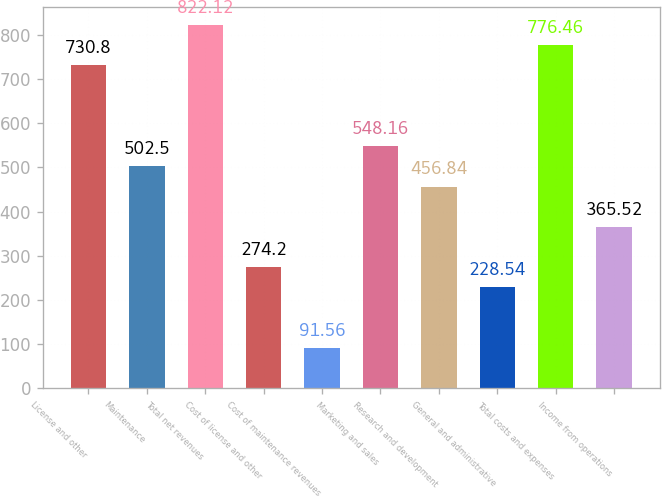Convert chart. <chart><loc_0><loc_0><loc_500><loc_500><bar_chart><fcel>License and other<fcel>Maintenance<fcel>Total net revenues<fcel>Cost of license and other<fcel>Cost of maintenance revenues<fcel>Marketing and sales<fcel>Research and development<fcel>General and administrative<fcel>Total costs and expenses<fcel>Income from operations<nl><fcel>730.8<fcel>502.5<fcel>822.12<fcel>274.2<fcel>91.56<fcel>548.16<fcel>456.84<fcel>228.54<fcel>776.46<fcel>365.52<nl></chart> 